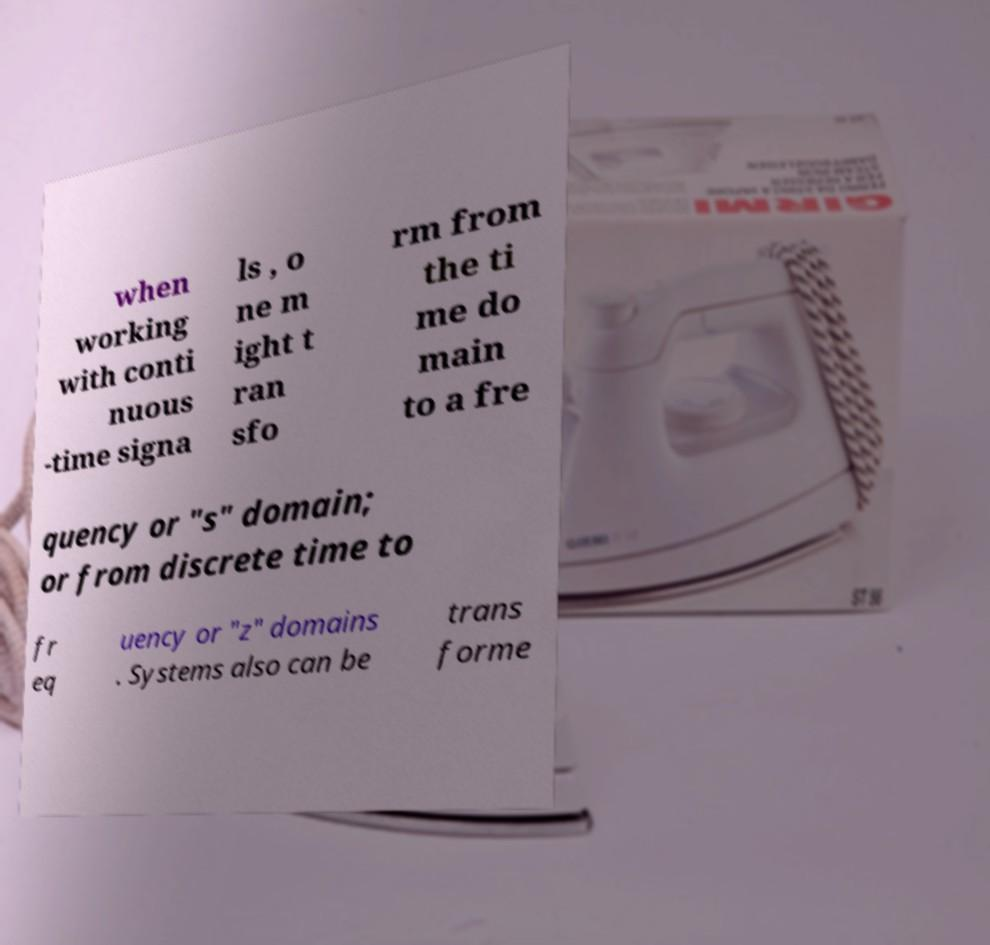What messages or text are displayed in this image? I need them in a readable, typed format. when working with conti nuous -time signa ls , o ne m ight t ran sfo rm from the ti me do main to a fre quency or "s" domain; or from discrete time to fr eq uency or "z" domains . Systems also can be trans forme 